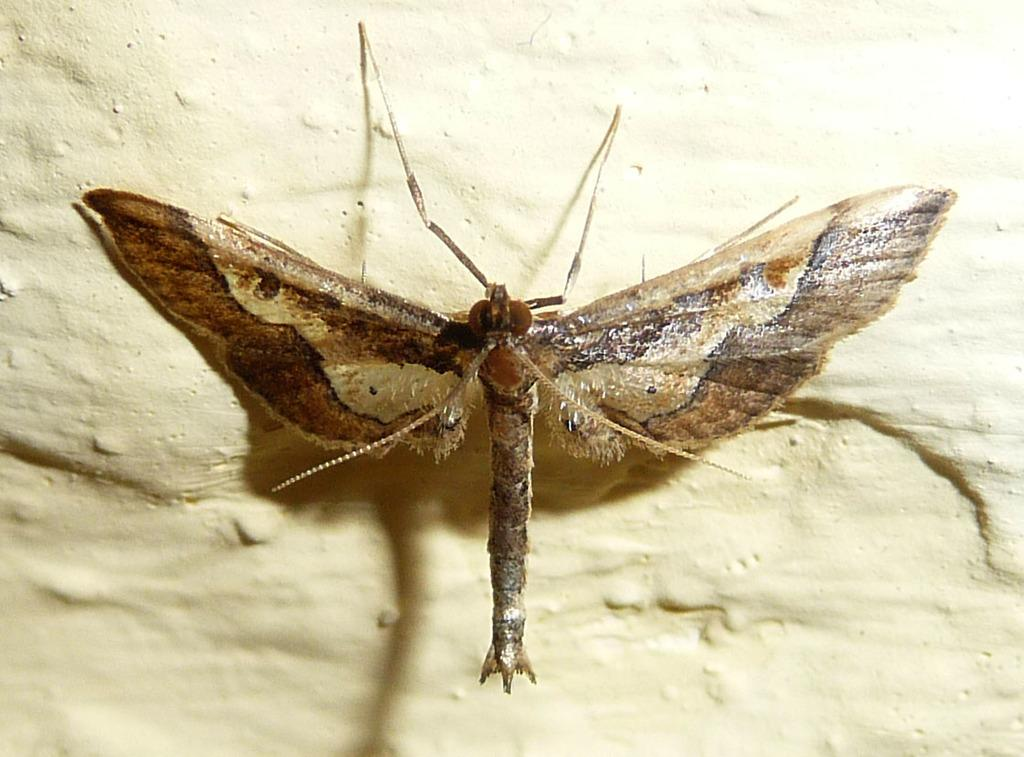What is present on the wall in the image? There is an insect on the wall in the image. Can you describe the insect's location on the wall? The insect is on the wall in the image. What news is the insect delivering in the image? There is no indication in the image that the insect is delivering any news. 